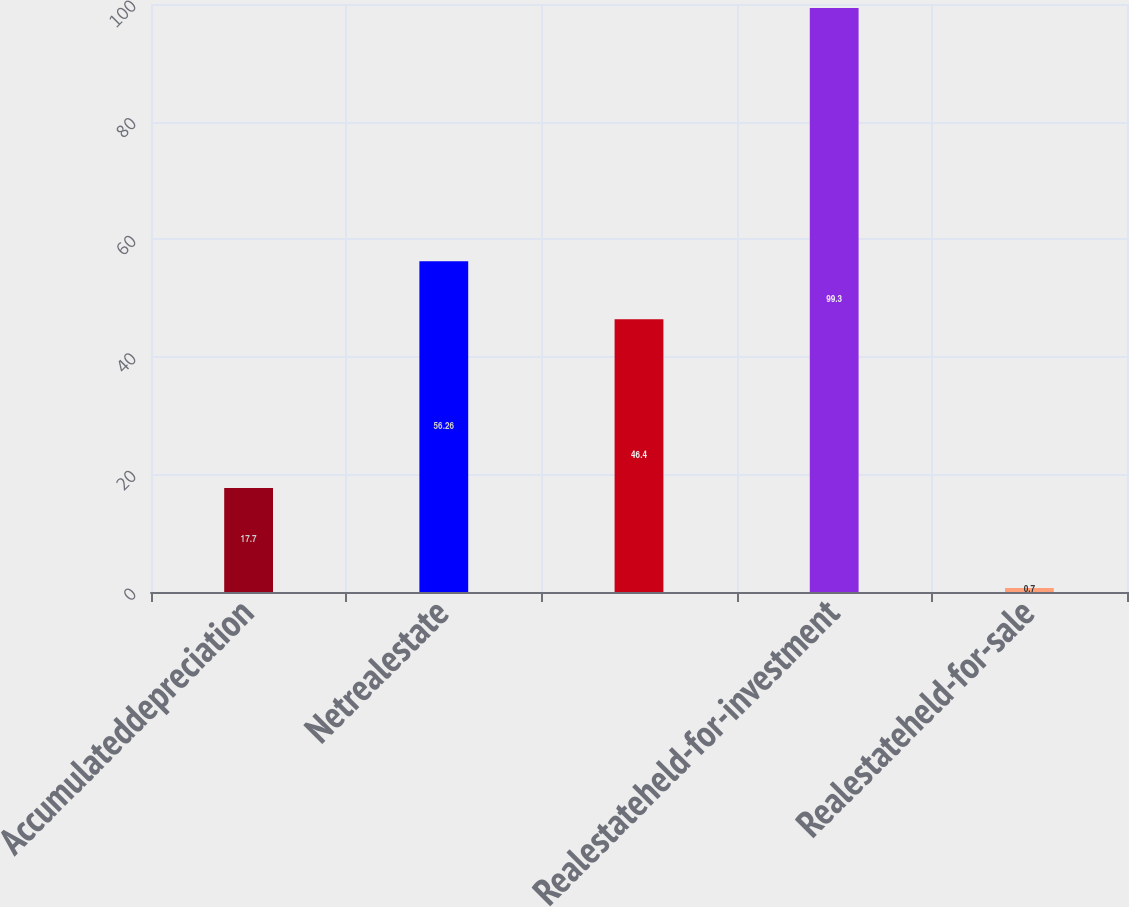<chart> <loc_0><loc_0><loc_500><loc_500><bar_chart><fcel>Accumulateddepreciation<fcel>Netrealestate<fcel>Unnamed: 2<fcel>Realestateheld-for-investment<fcel>Realestateheld-for-sale<nl><fcel>17.7<fcel>56.26<fcel>46.4<fcel>99.3<fcel>0.7<nl></chart> 